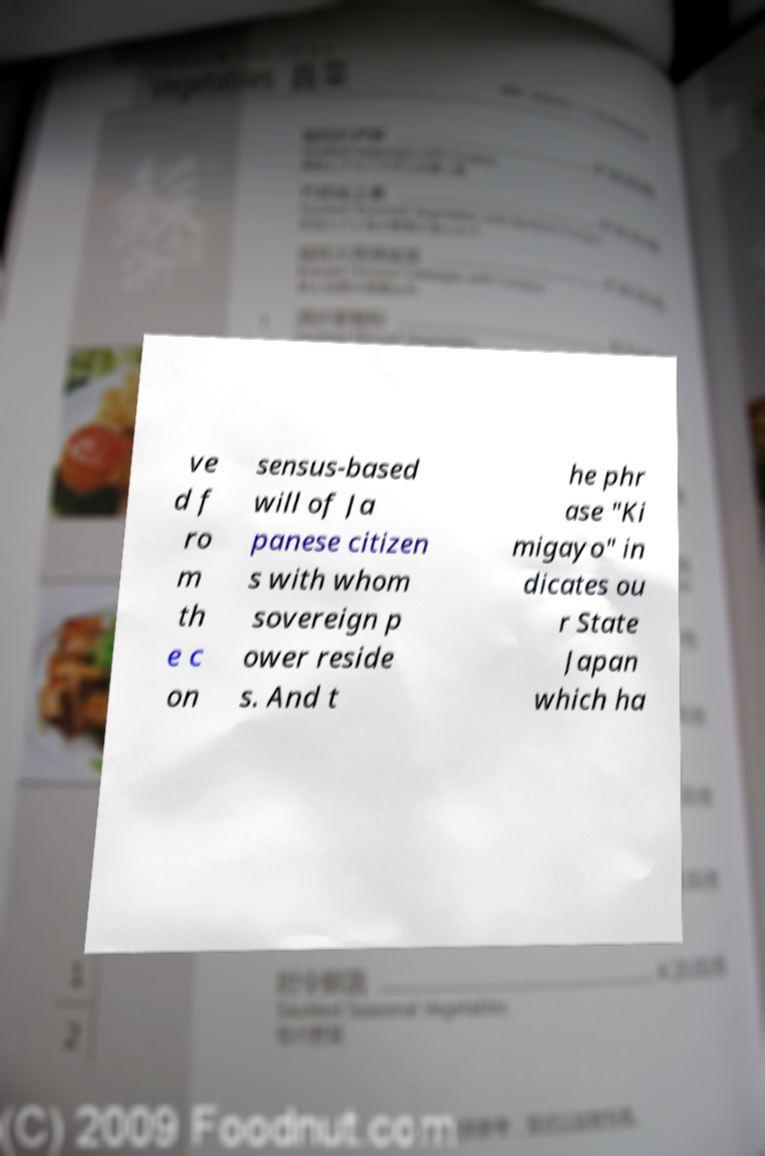For documentation purposes, I need the text within this image transcribed. Could you provide that? ve d f ro m th e c on sensus-based will of Ja panese citizen s with whom sovereign p ower reside s. And t he phr ase "Ki migayo" in dicates ou r State Japan which ha 